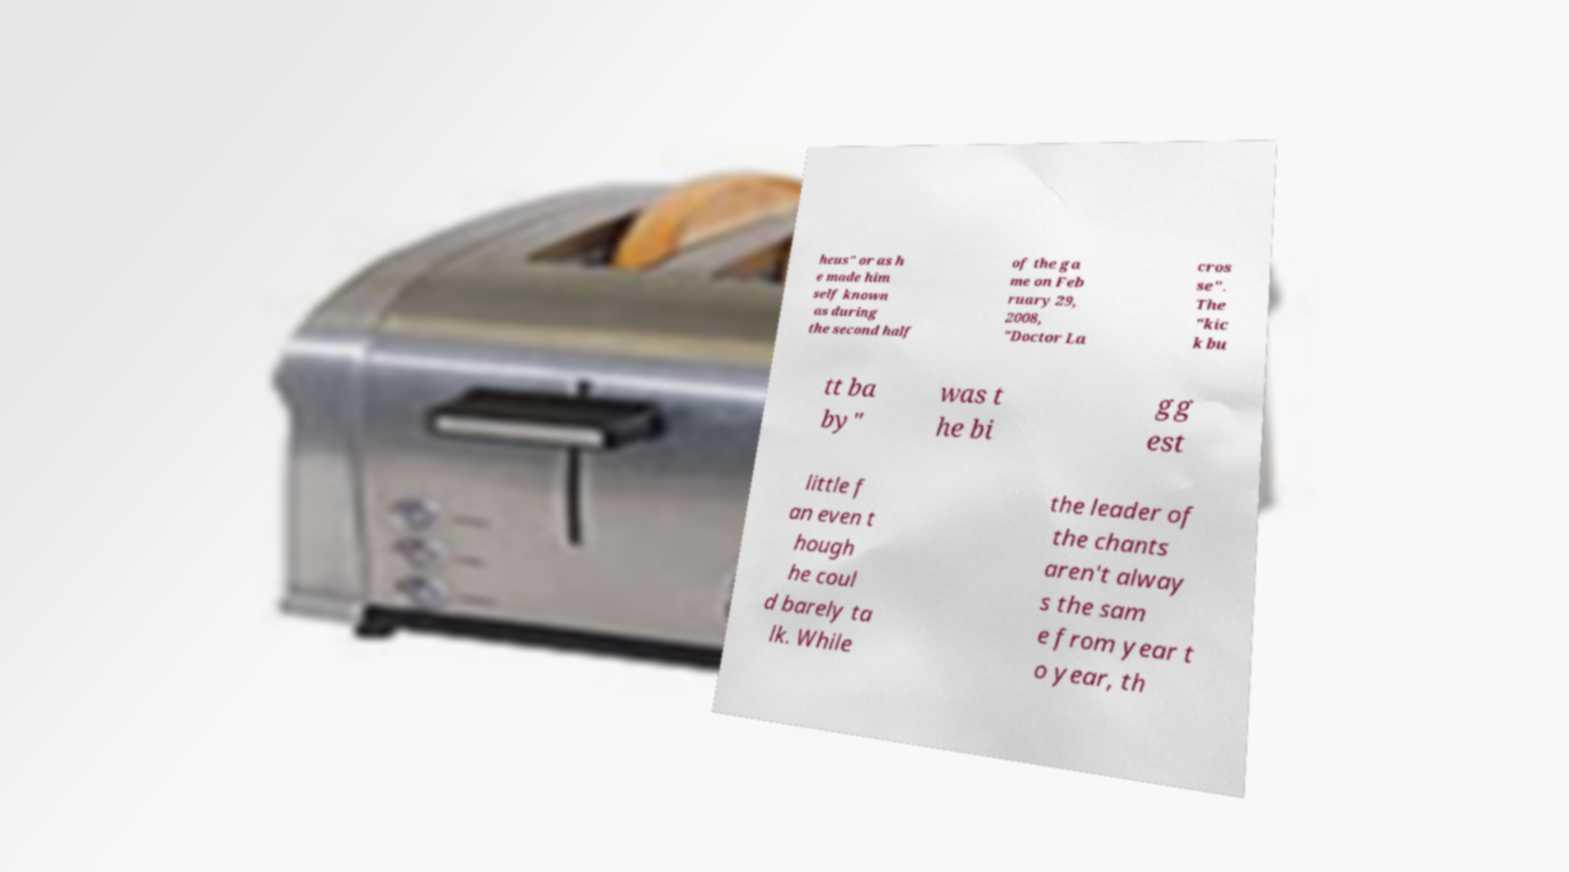Could you assist in decoding the text presented in this image and type it out clearly? heus" or as h e made him self known as during the second half of the ga me on Feb ruary 29, 2008, "Doctor La cros se". The "kic k bu tt ba by" was t he bi gg est little f an even t hough he coul d barely ta lk. While the leader of the chants aren't alway s the sam e from year t o year, th 